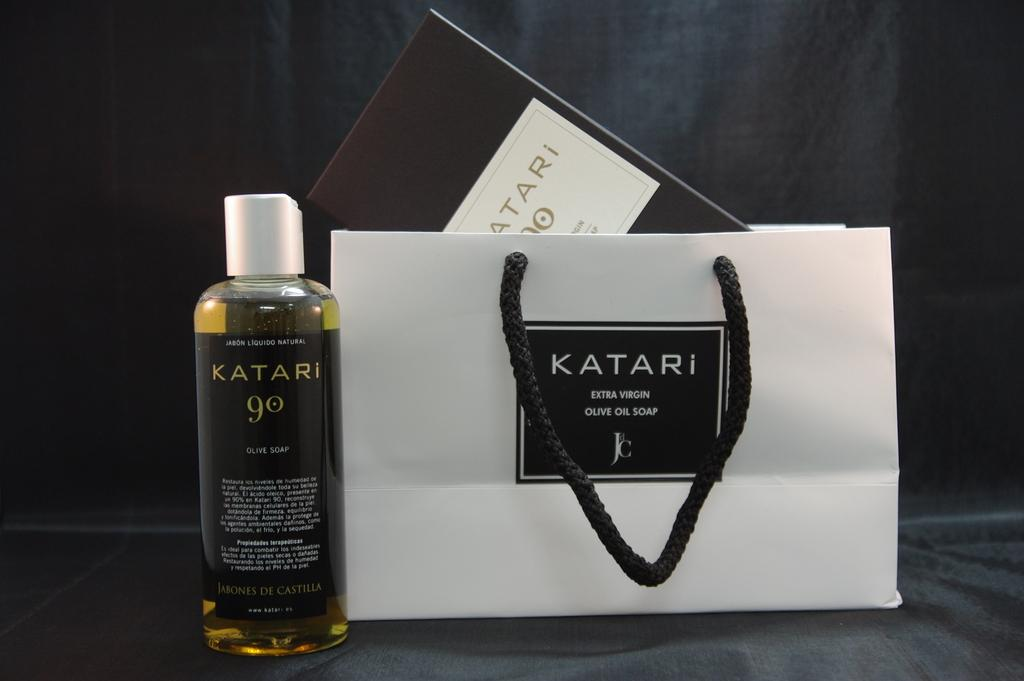<image>
Create a compact narrative representing the image presented. A bottle with the word Katari written in gold on in sits next to a bag with the same logo. 